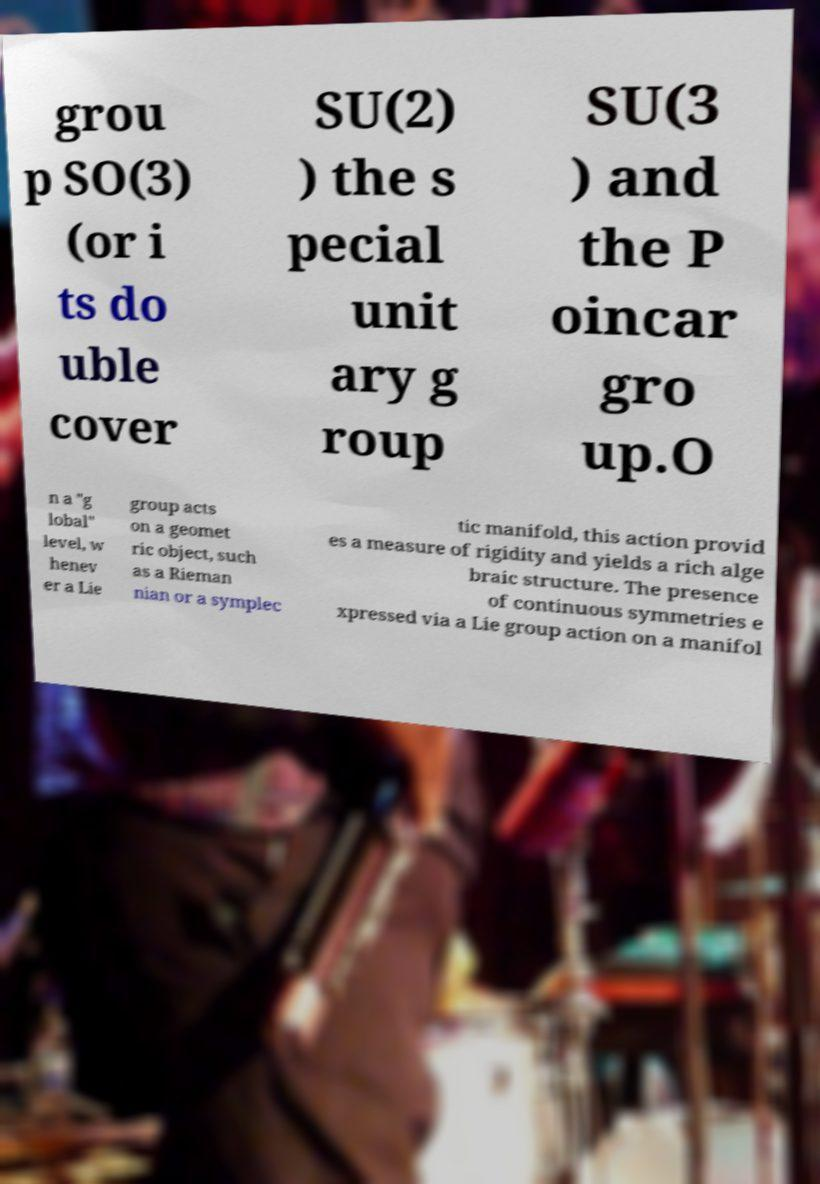Can you accurately transcribe the text from the provided image for me? grou p SO(3) (or i ts do uble cover SU(2) ) the s pecial unit ary g roup SU(3 ) and the P oincar gro up.O n a "g lobal" level, w henev er a Lie group acts on a geomet ric object, such as a Rieman nian or a symplec tic manifold, this action provid es a measure of rigidity and yields a rich alge braic structure. The presence of continuous symmetries e xpressed via a Lie group action on a manifol 